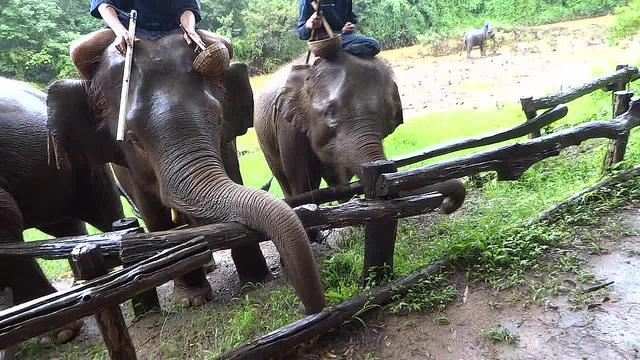What animals are present in the image? elephants 